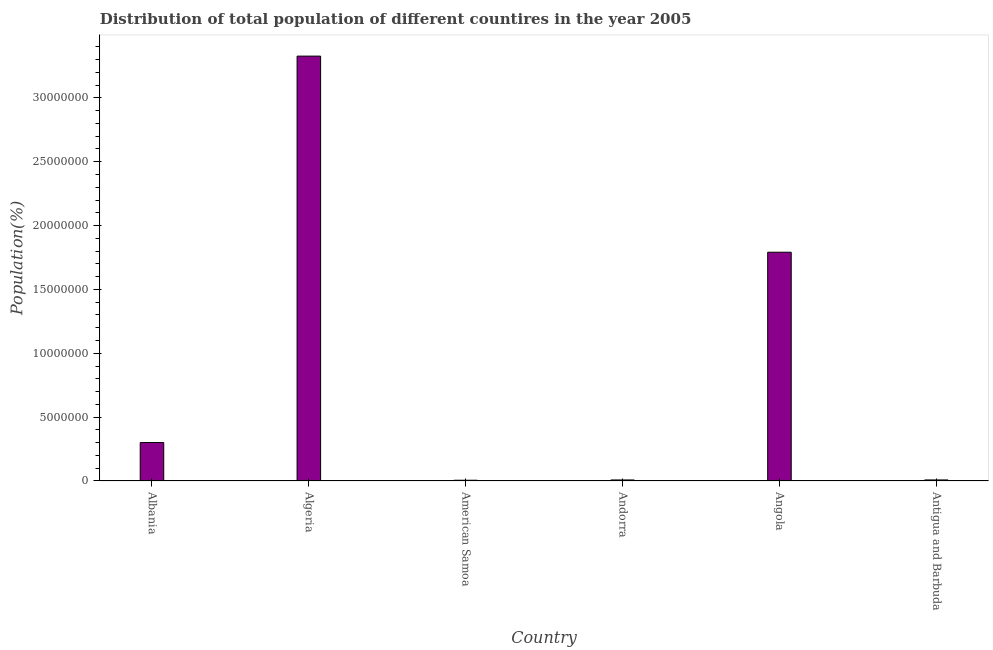What is the title of the graph?
Offer a very short reply. Distribution of total population of different countires in the year 2005. What is the label or title of the Y-axis?
Offer a terse response. Population(%). What is the population in Antigua and Barbuda?
Provide a succinct answer. 8.26e+04. Across all countries, what is the maximum population?
Provide a short and direct response. 3.33e+07. Across all countries, what is the minimum population?
Your answer should be compact. 5.91e+04. In which country was the population maximum?
Ensure brevity in your answer.  Algeria. In which country was the population minimum?
Provide a short and direct response. American Samoa. What is the sum of the population?
Offer a terse response. 5.44e+07. What is the difference between the population in Albania and Andorra?
Your response must be concise. 2.93e+06. What is the average population per country?
Ensure brevity in your answer.  9.07e+06. What is the median population?
Provide a succinct answer. 1.55e+06. What is the ratio of the population in Andorra to that in Angola?
Provide a short and direct response. 0.01. What is the difference between the highest and the second highest population?
Your answer should be compact. 1.54e+07. What is the difference between the highest and the lowest population?
Keep it short and to the point. 3.32e+07. In how many countries, is the population greater than the average population taken over all countries?
Your answer should be very brief. 2. How many countries are there in the graph?
Ensure brevity in your answer.  6. What is the difference between two consecutive major ticks on the Y-axis?
Provide a short and direct response. 5.00e+06. Are the values on the major ticks of Y-axis written in scientific E-notation?
Your answer should be very brief. No. What is the Population(%) in Albania?
Your response must be concise. 3.01e+06. What is the Population(%) in Algeria?
Your answer should be compact. 3.33e+07. What is the Population(%) of American Samoa?
Keep it short and to the point. 5.91e+04. What is the Population(%) in Andorra?
Keep it short and to the point. 8.12e+04. What is the Population(%) of Angola?
Provide a succinct answer. 1.79e+07. What is the Population(%) in Antigua and Barbuda?
Your response must be concise. 8.26e+04. What is the difference between the Population(%) in Albania and Algeria?
Your answer should be compact. -3.03e+07. What is the difference between the Population(%) in Albania and American Samoa?
Offer a very short reply. 2.95e+06. What is the difference between the Population(%) in Albania and Andorra?
Provide a succinct answer. 2.93e+06. What is the difference between the Population(%) in Albania and Angola?
Provide a succinct answer. -1.49e+07. What is the difference between the Population(%) in Albania and Antigua and Barbuda?
Make the answer very short. 2.93e+06. What is the difference between the Population(%) in Algeria and American Samoa?
Ensure brevity in your answer.  3.32e+07. What is the difference between the Population(%) in Algeria and Andorra?
Provide a short and direct response. 3.32e+07. What is the difference between the Population(%) in Algeria and Angola?
Ensure brevity in your answer.  1.54e+07. What is the difference between the Population(%) in Algeria and Antigua and Barbuda?
Provide a succinct answer. 3.32e+07. What is the difference between the Population(%) in American Samoa and Andorra?
Give a very brief answer. -2.21e+04. What is the difference between the Population(%) in American Samoa and Angola?
Make the answer very short. -1.79e+07. What is the difference between the Population(%) in American Samoa and Antigua and Barbuda?
Offer a very short reply. -2.34e+04. What is the difference between the Population(%) in Andorra and Angola?
Offer a very short reply. -1.78e+07. What is the difference between the Population(%) in Andorra and Antigua and Barbuda?
Provide a succinct answer. -1342. What is the difference between the Population(%) in Angola and Antigua and Barbuda?
Your answer should be compact. 1.78e+07. What is the ratio of the Population(%) in Albania to that in Algeria?
Offer a very short reply. 0.09. What is the ratio of the Population(%) in Albania to that in American Samoa?
Keep it short and to the point. 50.94. What is the ratio of the Population(%) in Albania to that in Andorra?
Your answer should be very brief. 37.08. What is the ratio of the Population(%) in Albania to that in Angola?
Offer a terse response. 0.17. What is the ratio of the Population(%) in Albania to that in Antigua and Barbuda?
Provide a succinct answer. 36.47. What is the ratio of the Population(%) in Algeria to that in American Samoa?
Offer a very short reply. 562.75. What is the ratio of the Population(%) in Algeria to that in Andorra?
Make the answer very short. 409.59. What is the ratio of the Population(%) in Algeria to that in Angola?
Offer a very short reply. 1.86. What is the ratio of the Population(%) in Algeria to that in Antigua and Barbuda?
Ensure brevity in your answer.  402.93. What is the ratio of the Population(%) in American Samoa to that in Andorra?
Your response must be concise. 0.73. What is the ratio of the Population(%) in American Samoa to that in Angola?
Your answer should be very brief. 0. What is the ratio of the Population(%) in American Samoa to that in Antigua and Barbuda?
Your answer should be very brief. 0.72. What is the ratio of the Population(%) in Andorra to that in Angola?
Your response must be concise. 0.01. What is the ratio of the Population(%) in Angola to that in Antigua and Barbuda?
Your answer should be very brief. 216.96. 